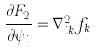<formula> <loc_0><loc_0><loc_500><loc_500>\frac { \partial F _ { 2 } } { \partial \psi _ { i } } = \nabla ^ { 2 } _ { i k } f _ { k }</formula> 